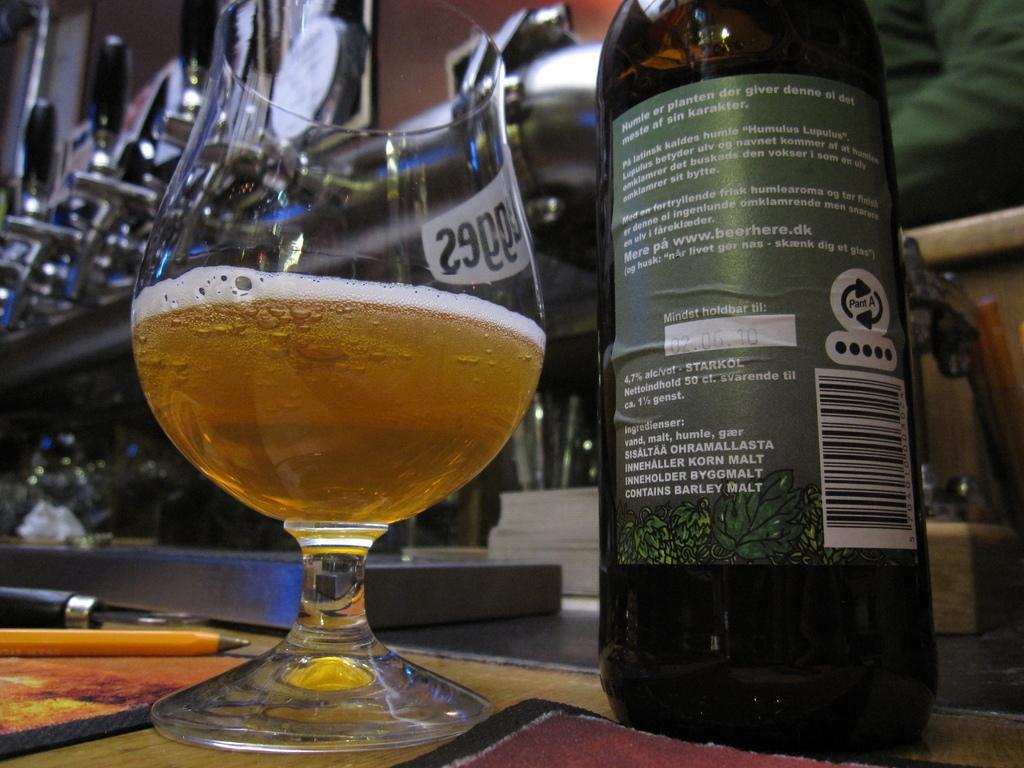Can you describe this image briefly? In this picture we can see bottle with sticker to it and a glass with drink in it this are on table and we can see pencil, pen on same table. 